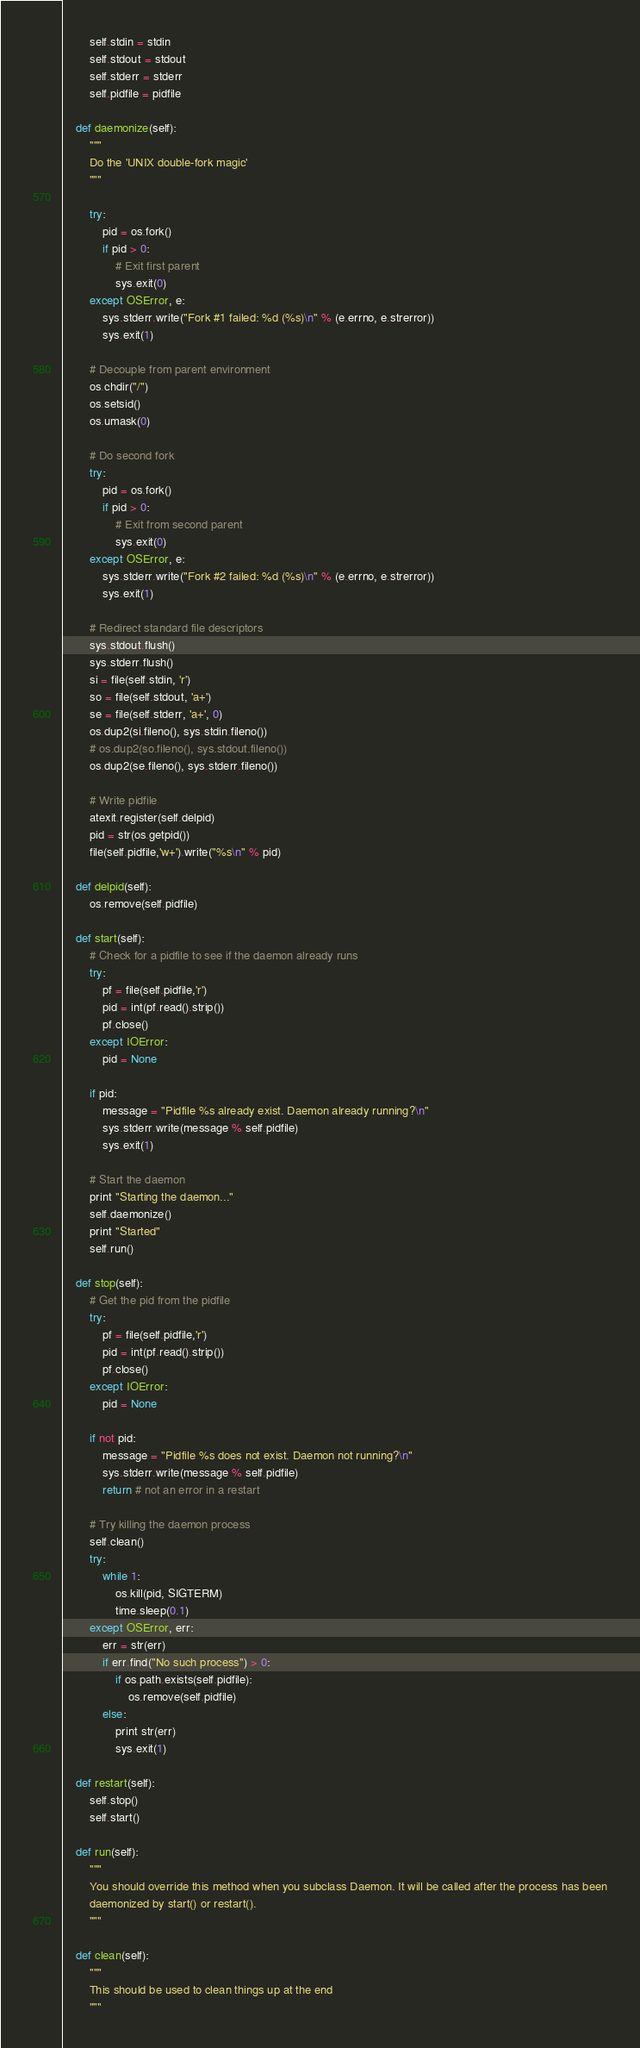Convert code to text. <code><loc_0><loc_0><loc_500><loc_500><_Python_>        self.stdin = stdin
        self.stdout = stdout
        self.stderr = stderr
        self.pidfile = pidfile

    def daemonize(self):
        """
        Do the 'UNIX double-fork magic'
        """

        try:
            pid = os.fork()
            if pid > 0:
                # Exit first parent
                sys.exit(0)
        except OSError, e:
            sys.stderr.write("Fork #1 failed: %d (%s)\n" % (e.errno, e.strerror))
            sys.exit(1)

        # Decouple from parent environment
        os.chdir("/")
        os.setsid()
        os.umask(0)

        # Do second fork
        try:
            pid = os.fork()
            if pid > 0:
                # Exit from second parent
                sys.exit(0)
        except OSError, e:
            sys.stderr.write("Fork #2 failed: %d (%s)\n" % (e.errno, e.strerror))
            sys.exit(1)

        # Redirect standard file descriptors
        sys.stdout.flush()
        sys.stderr.flush()
        si = file(self.stdin, 'r')
        so = file(self.stdout, 'a+')
        se = file(self.stderr, 'a+', 0)
        os.dup2(si.fileno(), sys.stdin.fileno())
        # os.dup2(so.fileno(), sys.stdout.fileno())
        os.dup2(se.fileno(), sys.stderr.fileno())

        # Write pidfile
        atexit.register(self.delpid)
        pid = str(os.getpid())
        file(self.pidfile,'w+').write("%s\n" % pid)

    def delpid(self):
        os.remove(self.pidfile)

    def start(self):
        # Check for a pidfile to see if the daemon already runs
        try:
            pf = file(self.pidfile,'r')
            pid = int(pf.read().strip())
            pf.close()
        except IOError:
            pid = None

        if pid:
            message = "Pidfile %s already exist. Daemon already running?\n"
            sys.stderr.write(message % self.pidfile)
            sys.exit(1)

        # Start the daemon
        print "Starting the daemon..."
        self.daemonize()
        print "Started"
        self.run()

    def stop(self):
        # Get the pid from the pidfile
        try:
            pf = file(self.pidfile,'r')
            pid = int(pf.read().strip())
            pf.close()
        except IOError:
            pid = None

        if not pid:
            message = "Pidfile %s does not exist. Daemon not running?\n"
            sys.stderr.write(message % self.pidfile)
            return # not an error in a restart

        # Try killing the daemon process
        self.clean()
        try:
            while 1:
                os.kill(pid, SIGTERM)
                time.sleep(0.1)
        except OSError, err:
            err = str(err)
            if err.find("No such process") > 0:
                if os.path.exists(self.pidfile):
                    os.remove(self.pidfile)
            else:
                print str(err)
                sys.exit(1)

    def restart(self):
        self.stop()
        self.start()

    def run(self):
        """
        You should override this method when you subclass Daemon. It will be called after the process has been
        daemonized by start() or restart().
        """

    def clean(self):
        """
        This should be used to clean things up at the end
        """
</code> 